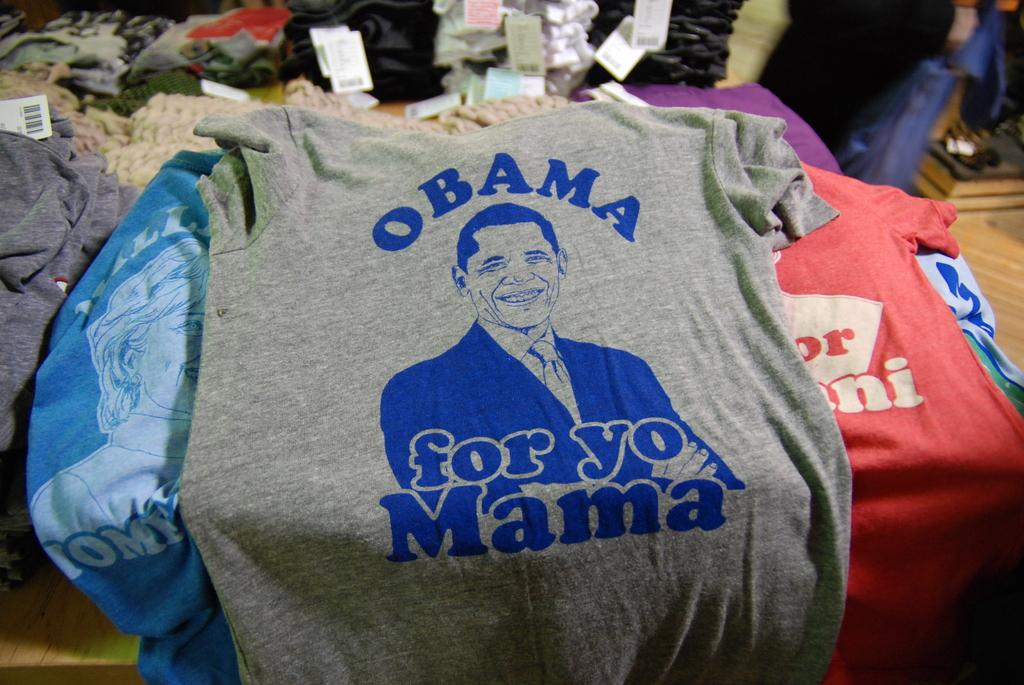Provide a one-sentence caption for the provided image. T-shirts on a table with the words Obama for yo Mama with picture. 